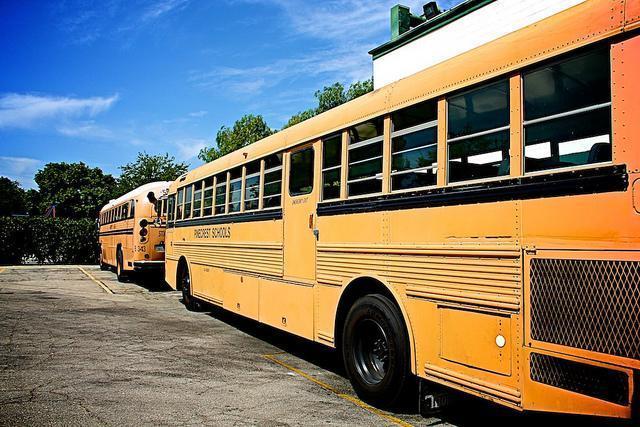How many buses are there?
Give a very brief answer. 2. How many buses are visible?
Give a very brief answer. 2. 